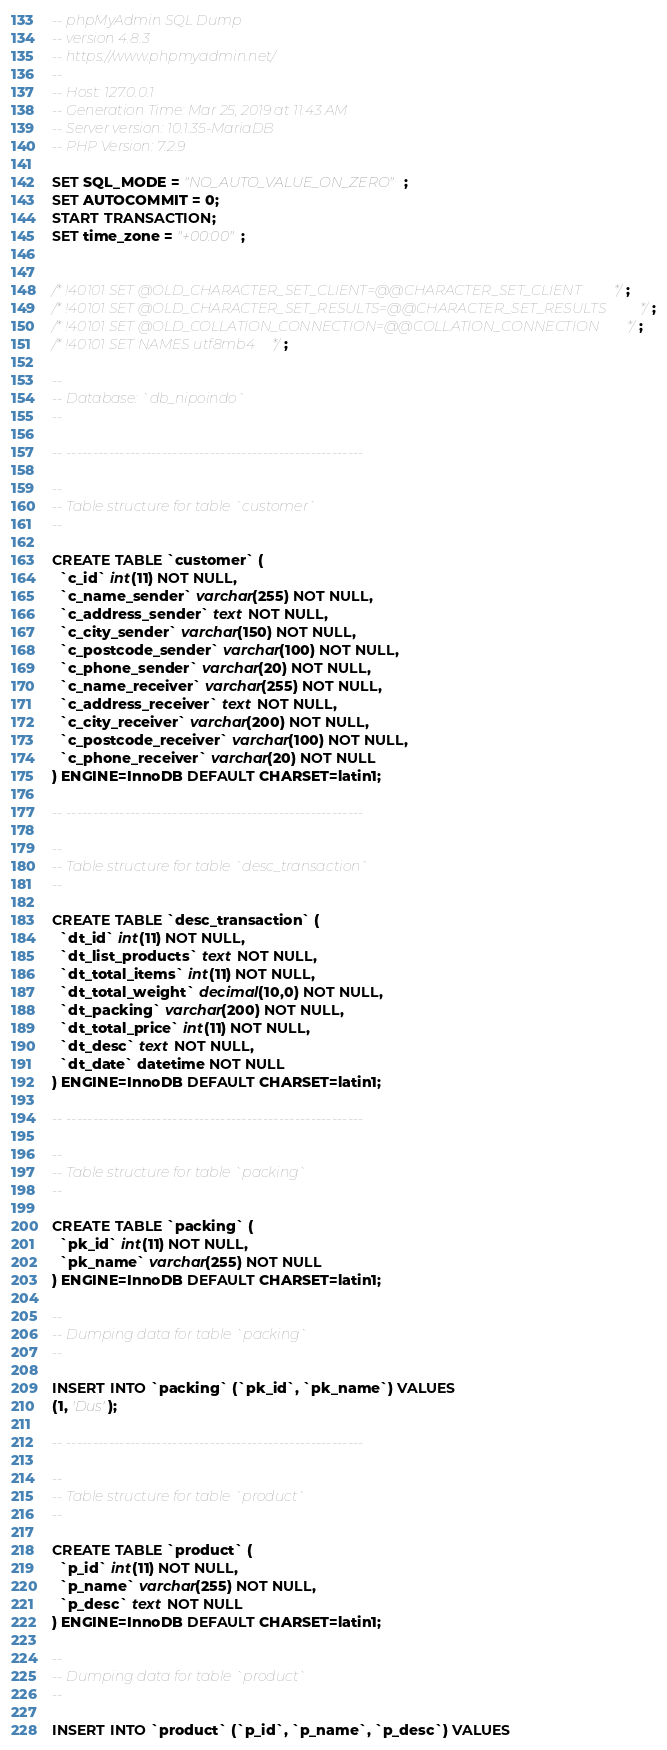Convert code to text. <code><loc_0><loc_0><loc_500><loc_500><_SQL_>-- phpMyAdmin SQL Dump
-- version 4.8.3
-- https://www.phpmyadmin.net/
--
-- Host: 127.0.0.1
-- Generation Time: Mar 25, 2019 at 11:43 AM
-- Server version: 10.1.35-MariaDB
-- PHP Version: 7.2.9

SET SQL_MODE = "NO_AUTO_VALUE_ON_ZERO";
SET AUTOCOMMIT = 0;
START TRANSACTION;
SET time_zone = "+00:00";


/*!40101 SET @OLD_CHARACTER_SET_CLIENT=@@CHARACTER_SET_CLIENT */;
/*!40101 SET @OLD_CHARACTER_SET_RESULTS=@@CHARACTER_SET_RESULTS */;
/*!40101 SET @OLD_COLLATION_CONNECTION=@@COLLATION_CONNECTION */;
/*!40101 SET NAMES utf8mb4 */;

--
-- Database: `db_nipoindo`
--

-- --------------------------------------------------------

--
-- Table structure for table `customer`
--

CREATE TABLE `customer` (
  `c_id` int(11) NOT NULL,
  `c_name_sender` varchar(255) NOT NULL,
  `c_address_sender` text NOT NULL,
  `c_city_sender` varchar(150) NOT NULL,
  `c_postcode_sender` varchar(100) NOT NULL,
  `c_phone_sender` varchar(20) NOT NULL,
  `c_name_receiver` varchar(255) NOT NULL,
  `c_address_receiver` text NOT NULL,
  `c_city_receiver` varchar(200) NOT NULL,
  `c_postcode_receiver` varchar(100) NOT NULL,
  `c_phone_receiver` varchar(20) NOT NULL
) ENGINE=InnoDB DEFAULT CHARSET=latin1;

-- --------------------------------------------------------

--
-- Table structure for table `desc_transaction`
--

CREATE TABLE `desc_transaction` (
  `dt_id` int(11) NOT NULL,
  `dt_list_products` text NOT NULL,
  `dt_total_items` int(11) NOT NULL,
  `dt_total_weight` decimal(10,0) NOT NULL,
  `dt_packing` varchar(200) NOT NULL,
  `dt_total_price` int(11) NOT NULL,
  `dt_desc` text NOT NULL,
  `dt_date` datetime NOT NULL
) ENGINE=InnoDB DEFAULT CHARSET=latin1;

-- --------------------------------------------------------

--
-- Table structure for table `packing`
--

CREATE TABLE `packing` (
  `pk_id` int(11) NOT NULL,
  `pk_name` varchar(255) NOT NULL
) ENGINE=InnoDB DEFAULT CHARSET=latin1;

--
-- Dumping data for table `packing`
--

INSERT INTO `packing` (`pk_id`, `pk_name`) VALUES
(1, 'Dus');

-- --------------------------------------------------------

--
-- Table structure for table `product`
--

CREATE TABLE `product` (
  `p_id` int(11) NOT NULL,
  `p_name` varchar(255) NOT NULL,
  `p_desc` text NOT NULL
) ENGINE=InnoDB DEFAULT CHARSET=latin1;

--
-- Dumping data for table `product`
--

INSERT INTO `product` (`p_id`, `p_name`, `p_desc`) VALUES</code> 